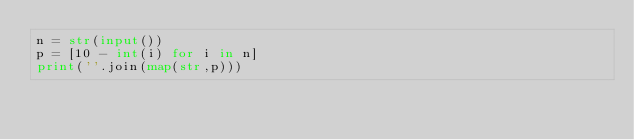<code> <loc_0><loc_0><loc_500><loc_500><_Python_>n = str(input())
p = [10 - int(i) for i in n]
print(''.join(map(str,p)))</code> 